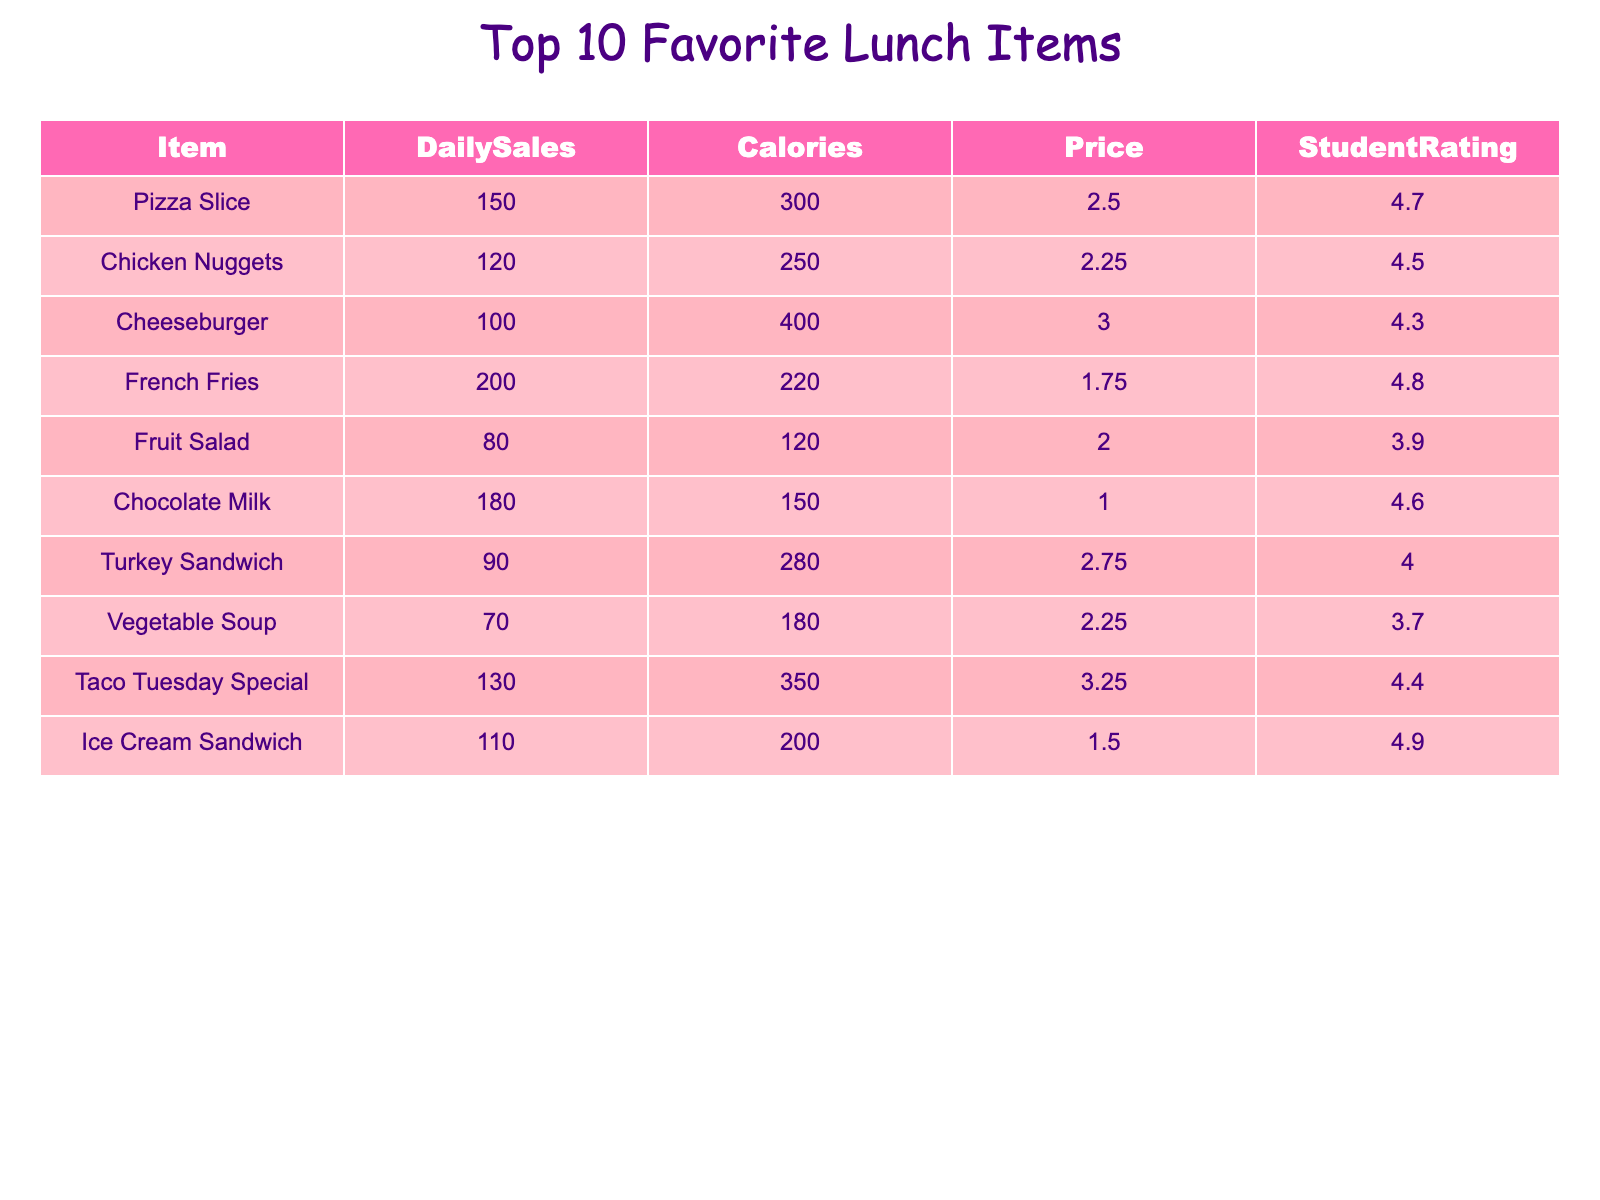What is the item with the highest daily sales? The daily sales column indicates the number of sales for each item. Looking through the values, Pizza Slice has the highest sales at 150.
Answer: Pizza Slice How many calories does a cheeseburger have? Referring to the calories column, the cheeseburger item shows a value of 400 calories.
Answer: 400 calories What is the price of the taco Tuesday special? Checking the price column for the Taco Tuesday Special shows it is priced at 3.25.
Answer: 3.25 Which item has the lowest student rating? Looking at the student rating column, the item with the lowest value is the fruit salad with a rating of 3.9.
Answer: Fruit Salad What is the total daily sales of chicken nuggets and turkey sandwich combined? By summing the daily sales of Chicken Nuggets (120) and Turkey Sandwich (90), we find 120 + 90 = 210.
Answer: 210 Is chocolate milk more popular than vegetable soup in terms of daily sales? Comparing the daily sales, chocolate milk has 180 while vegetable soup has 70. Since 180 > 70, chocolate milk is more popular.
Answer: Yes What is the average student rating of the top three items with the highest sales? The top three items by sales are Pizza Slice (4.7), French Fries (4.8), and Chocolate Milk (4.6). The average rating is (4.7 + 4.8 + 4.6) / 3 = 4.7.
Answer: 4.7 How many more calories does a cheeseburger have compared to a chicken nugget? The cheeseburger has 400 calories, while chicken nuggets have 250. Calculating the difference gives us 400 - 250 = 150.
Answer: 150 calories Identify the item with the second highest sales. The highest sales item is Pizza Slice, and looking at the daily sales, the second highest is French Fries with 200 sales.
Answer: French Fries What is the price range of all the lunch items listed? The highest price is 3.25 (Taco Tuesday Special) and the lowest is 1.00 (Chocolate Milk). Therefore, the price range is from 1.00 to 3.25.
Answer: 1.00 to 3.25 